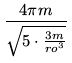<formula> <loc_0><loc_0><loc_500><loc_500>\frac { 4 \pi m } { \sqrt { 5 \cdot \frac { 3 m } { r o ^ { 3 } } } }</formula> 